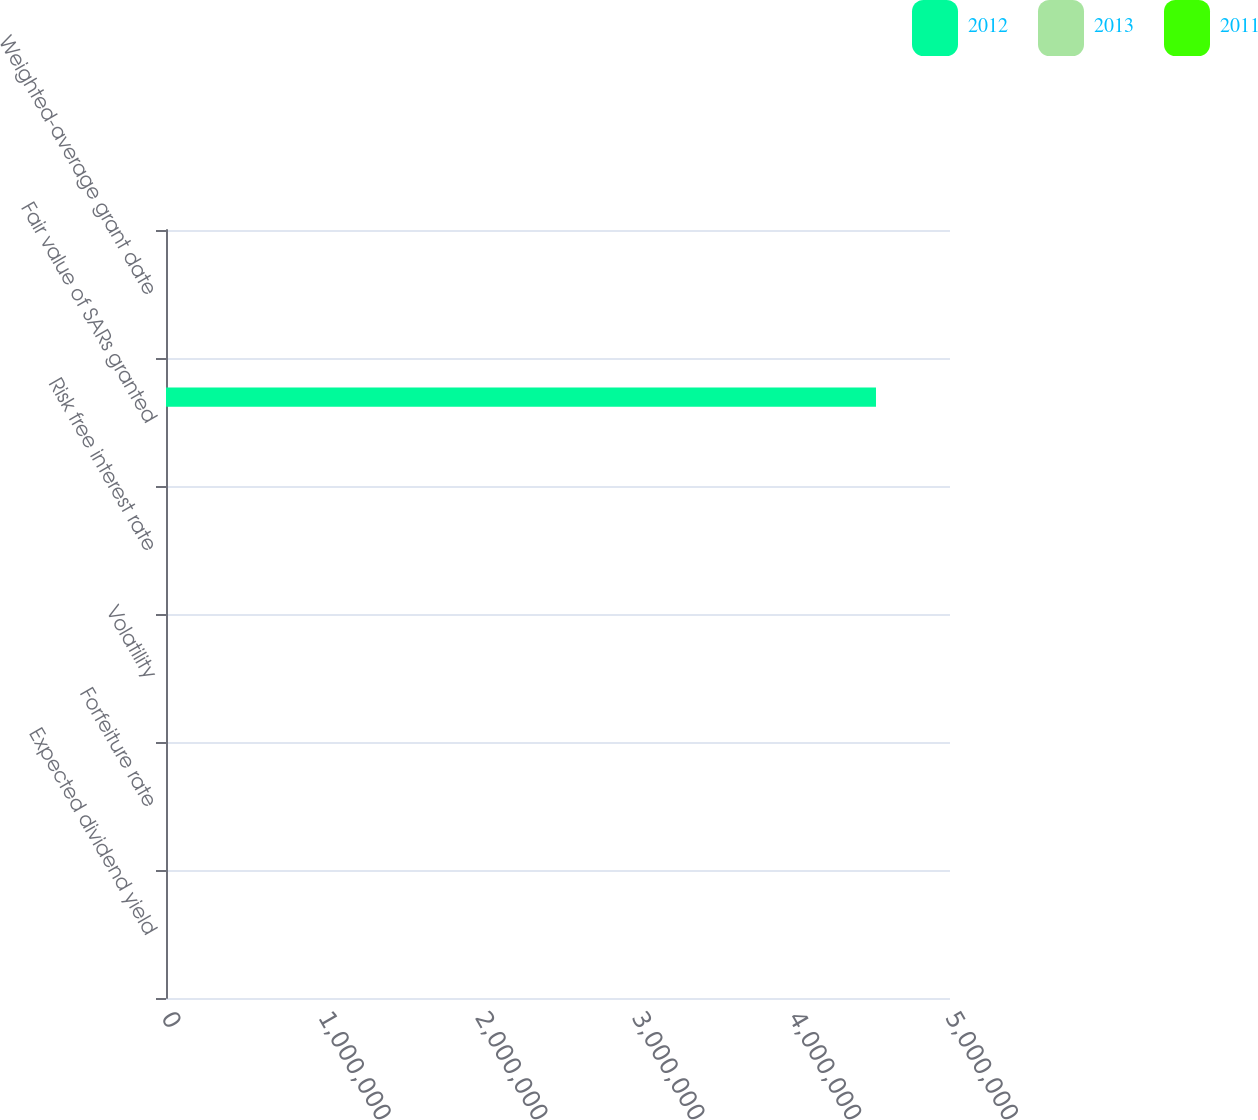Convert chart to OTSL. <chart><loc_0><loc_0><loc_500><loc_500><stacked_bar_chart><ecel><fcel>Expected dividend yield<fcel>Forfeiture rate<fcel>Volatility<fcel>Risk free interest rate<fcel>Fair value of SARs granted<fcel>Weighted-average grant date<nl><fcel>2012<fcel>0<fcel>10.31<fcel>32<fcel>0.82<fcel>4.528e+06<fcel>13.86<nl><fcel>2013<fcel>0<fcel>10.21<fcel>35.9<fcel>0.94<fcel>10.905<fcel>12.84<nl><fcel>2011<fcel>0<fcel>11.5<fcel>35.33<fcel>2.01<fcel>10.905<fcel>14.29<nl></chart> 